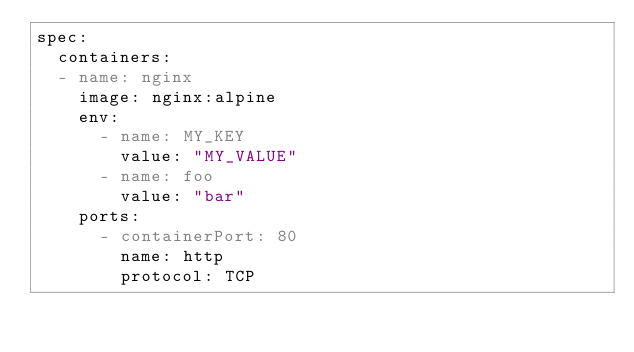<code> <loc_0><loc_0><loc_500><loc_500><_YAML_>spec:
  containers:
  - name: nginx
    image: nginx:alpine
    env:
      - name: MY_KEY
        value: "MY_VALUE"
      - name: foo
        value: "bar"
    ports:
      - containerPort: 80
        name: http
        protocol: TCP
</code> 